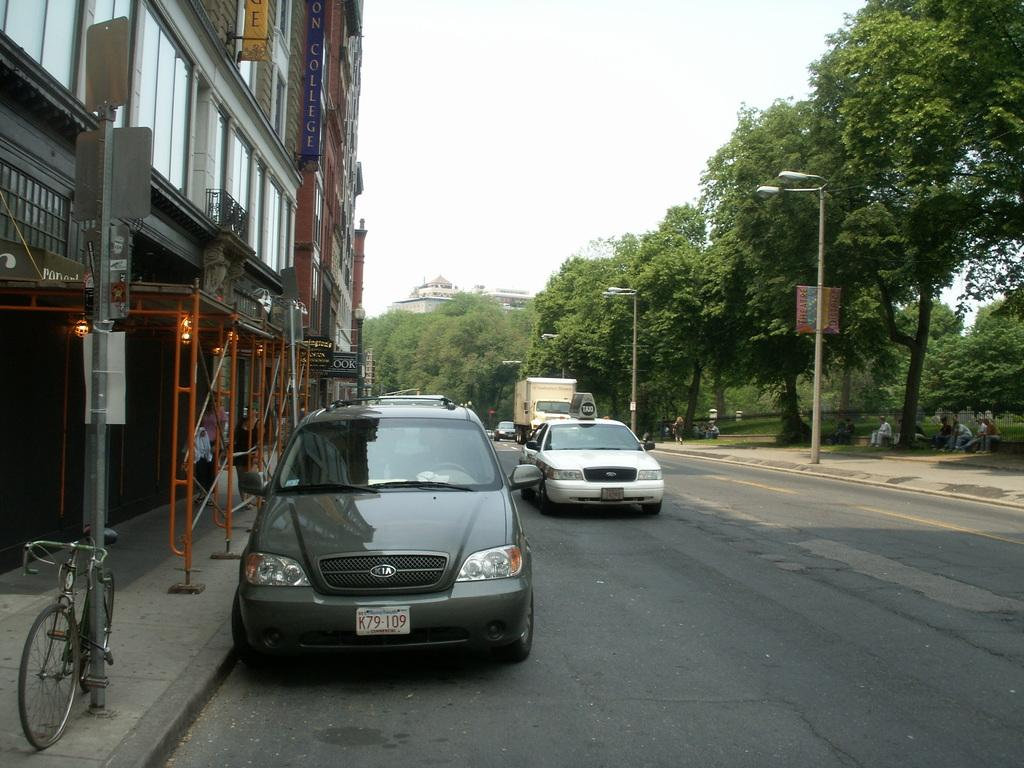What type of structures can be seen in the image? There are buildings in the image. What mode of transportation is present in the image? There is a bicycle, cars, and a truck in the image. What type of lighting is present in the image? There are street lamps in the image. What type of vegetation is present in the image? There are trees in the image. What part of the natural environment is visible in the image? The sky is visible in the image. What type of mitten is being used to navigate the spacecraft in the image? There is no spacecraft or mitten present in the image; it features buildings, vehicles, and street lamps. What is the end result of the journey depicted in the image? The image does not depict a journey or an end result; it shows a scene with buildings, vehicles, and street lamps. 